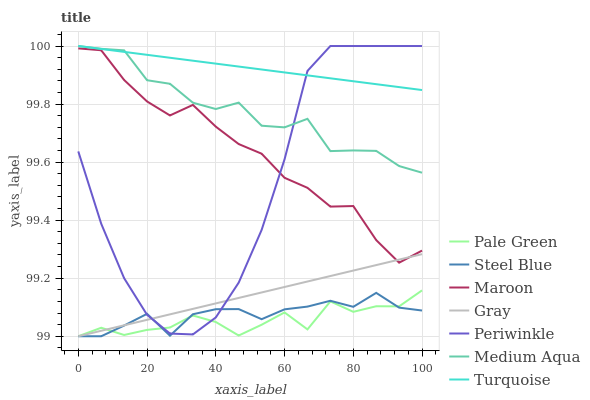Does Pale Green have the minimum area under the curve?
Answer yes or no. Yes. Does Steel Blue have the minimum area under the curve?
Answer yes or no. No. Does Steel Blue have the maximum area under the curve?
Answer yes or no. No. Is Turquoise the smoothest?
Answer yes or no. Yes. Is Medium Aqua the roughest?
Answer yes or no. Yes. Is Steel Blue the smoothest?
Answer yes or no. No. Is Steel Blue the roughest?
Answer yes or no. No. Does Turquoise have the lowest value?
Answer yes or no. No. Does Steel Blue have the highest value?
Answer yes or no. No. Is Maroon less than Medium Aqua?
Answer yes or no. Yes. Is Maroon greater than Pale Green?
Answer yes or no. Yes. Does Maroon intersect Medium Aqua?
Answer yes or no. No. 